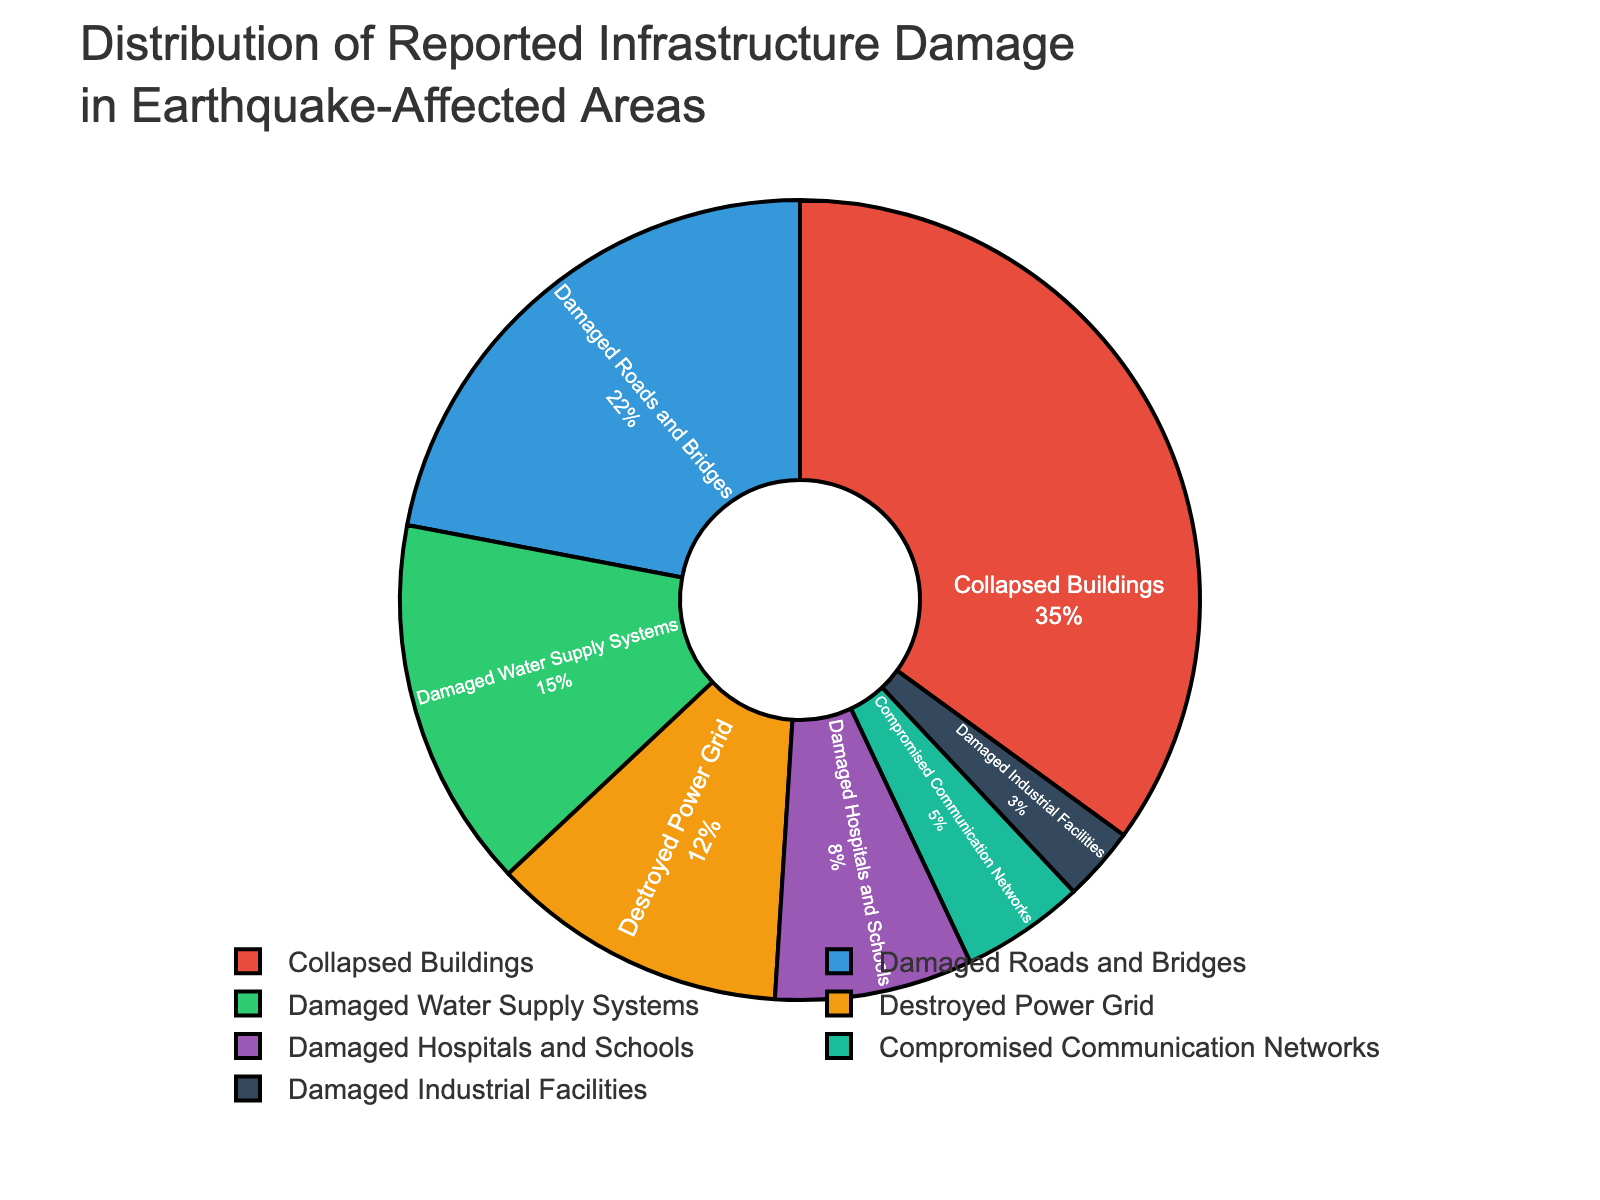What's the infrastructure damage type with the highest percentage? To find the infrastructure damage type with the highest percentage, look at the figure and identify the category with the largest proportion. From the data, "Collapsed Buildings" has the largest percentage of 35%.
Answer: Collapsed Buildings Which damage type has a smaller percentage: "Damaged Roads and Bridges" or "Destroyed Power Grid"? Compare the percentages for "Damaged Roads and Bridges" (22%) and "Destroyed Power Grid" (12%). Since 12% is less than 22%, "Destroyed Power Grid" has a smaller percentage.
Answer: Destroyed Power Grid What is the total percentage of "Damaged Roads and Bridges" and "Damaged Water Supply Systems"? Add the percentages of "Damaged Roads and Bridges" (22%) and "Damaged Water Supply Systems" (15%). The sum is 22% + 15% = 37%.
Answer: 37% How does the percentage of "Damaged Hospitals and Schools" compare to that of "Compromised Communication Networks"? Compare the percentages of "Damaged Hospitals and Schools" (8%) and "Compromised Communication Networks" (5%). Since 8% is greater than 5%, "Damaged Hospitals and Schools" has a higher percentage.
Answer: Damaged Hospitals and Schools What is the combined percentage of all damage types, excluding "Collapsed Buildings"? Subtract the percentage of "Collapsed Buildings" (35%) from the total (100%). Thus, 100% - 35% = 65%.
Answer: 65% Among the listed damage types, which has the least percentage? Identify the damage type with the smallest percentage. From the data, "Damaged Industrial Facilities" has the smallest percentage of 3%.
Answer: Damaged Industrial Facilities How much higher is the percentage of "Collapsed Buildings" compared to "Damaged Roads and Bridges"? Subtract the percentage of "Damaged Roads and Bridges" (22%) from "Collapsed Buildings" (35%). Therefore, 35% - 22% = 13%.
Answer: 13% Is the percentage of "Damaged Water Supply Systems" closer to the percentage of "Destroyed Power Grid" or "Damaged Roads and Bridges"? Compare the differences: "Damaged Water Supply Systems" (15%) and "Destroyed Power Grid" (12%) differ by 3%, while "Damaged Water Supply Systems" (15%) and "Damaged Roads and Bridges" (22%) differ by 7%. Hence, it is closer to "Destroyed Power Grid".
Answer: Destroyed Power Grid What percentage of reported damage is attributed to "Damaged Water Supply Systems" and "Damaged Hospitals and Schools" combined? Sum the percentages of "Damaged Water Supply Systems" (15%) and "Damaged Hospitals and Schools" (8%). The combined percentage is 15% + 8% = 23%.
Answer: 23% 